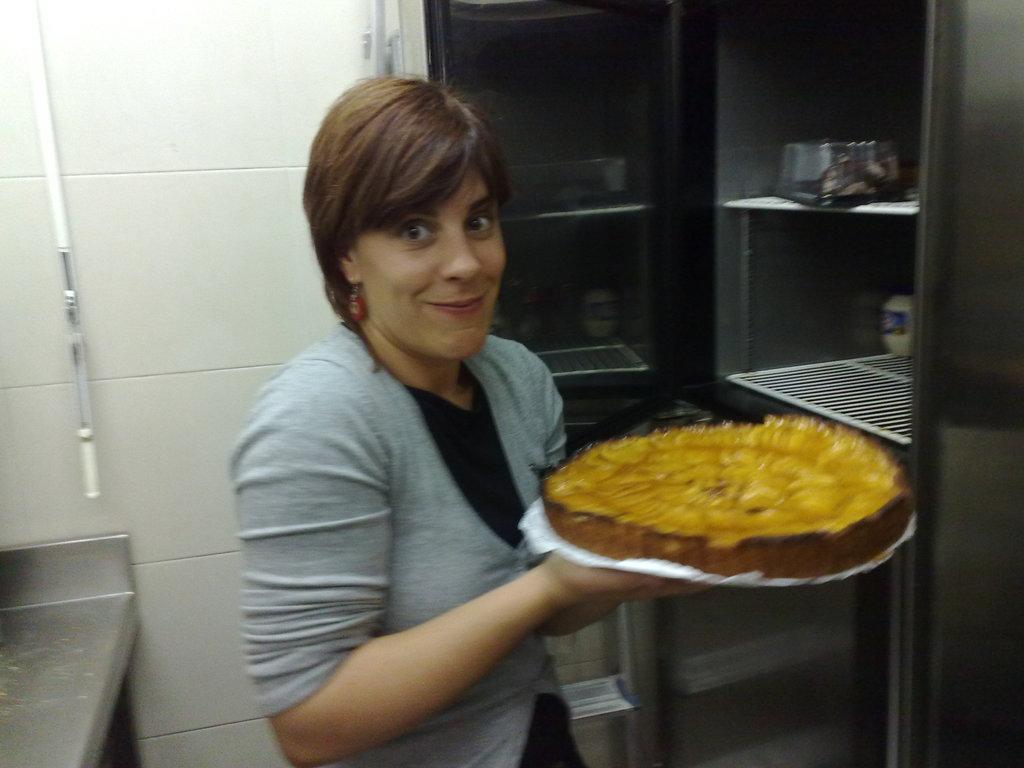Could you give a brief overview of what you see in this image? In this image there is a woman standing. She is smiling. She is holding food in her hand. In front of her there is a cupboard. There are boxes in the cupboard. Behind her there is a wall. To the bottom left there is a metal table. 